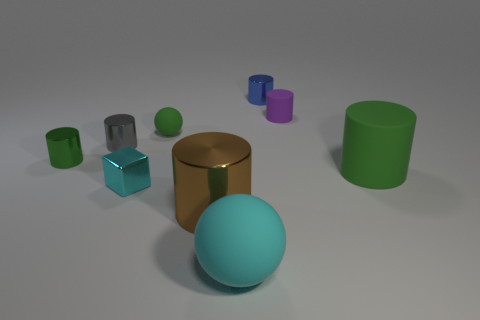Subtract 1 cylinders. How many cylinders are left? 5 Subtract all gray cylinders. How many cylinders are left? 5 Subtract all blue cylinders. How many cylinders are left? 5 Subtract all red cylinders. Subtract all cyan spheres. How many cylinders are left? 6 Subtract all cubes. How many objects are left? 8 Add 3 brown metal objects. How many brown metal objects exist? 4 Subtract 0 yellow cylinders. How many objects are left? 9 Subtract all large gray matte blocks. Subtract all small purple matte cylinders. How many objects are left? 8 Add 7 cyan things. How many cyan things are left? 9 